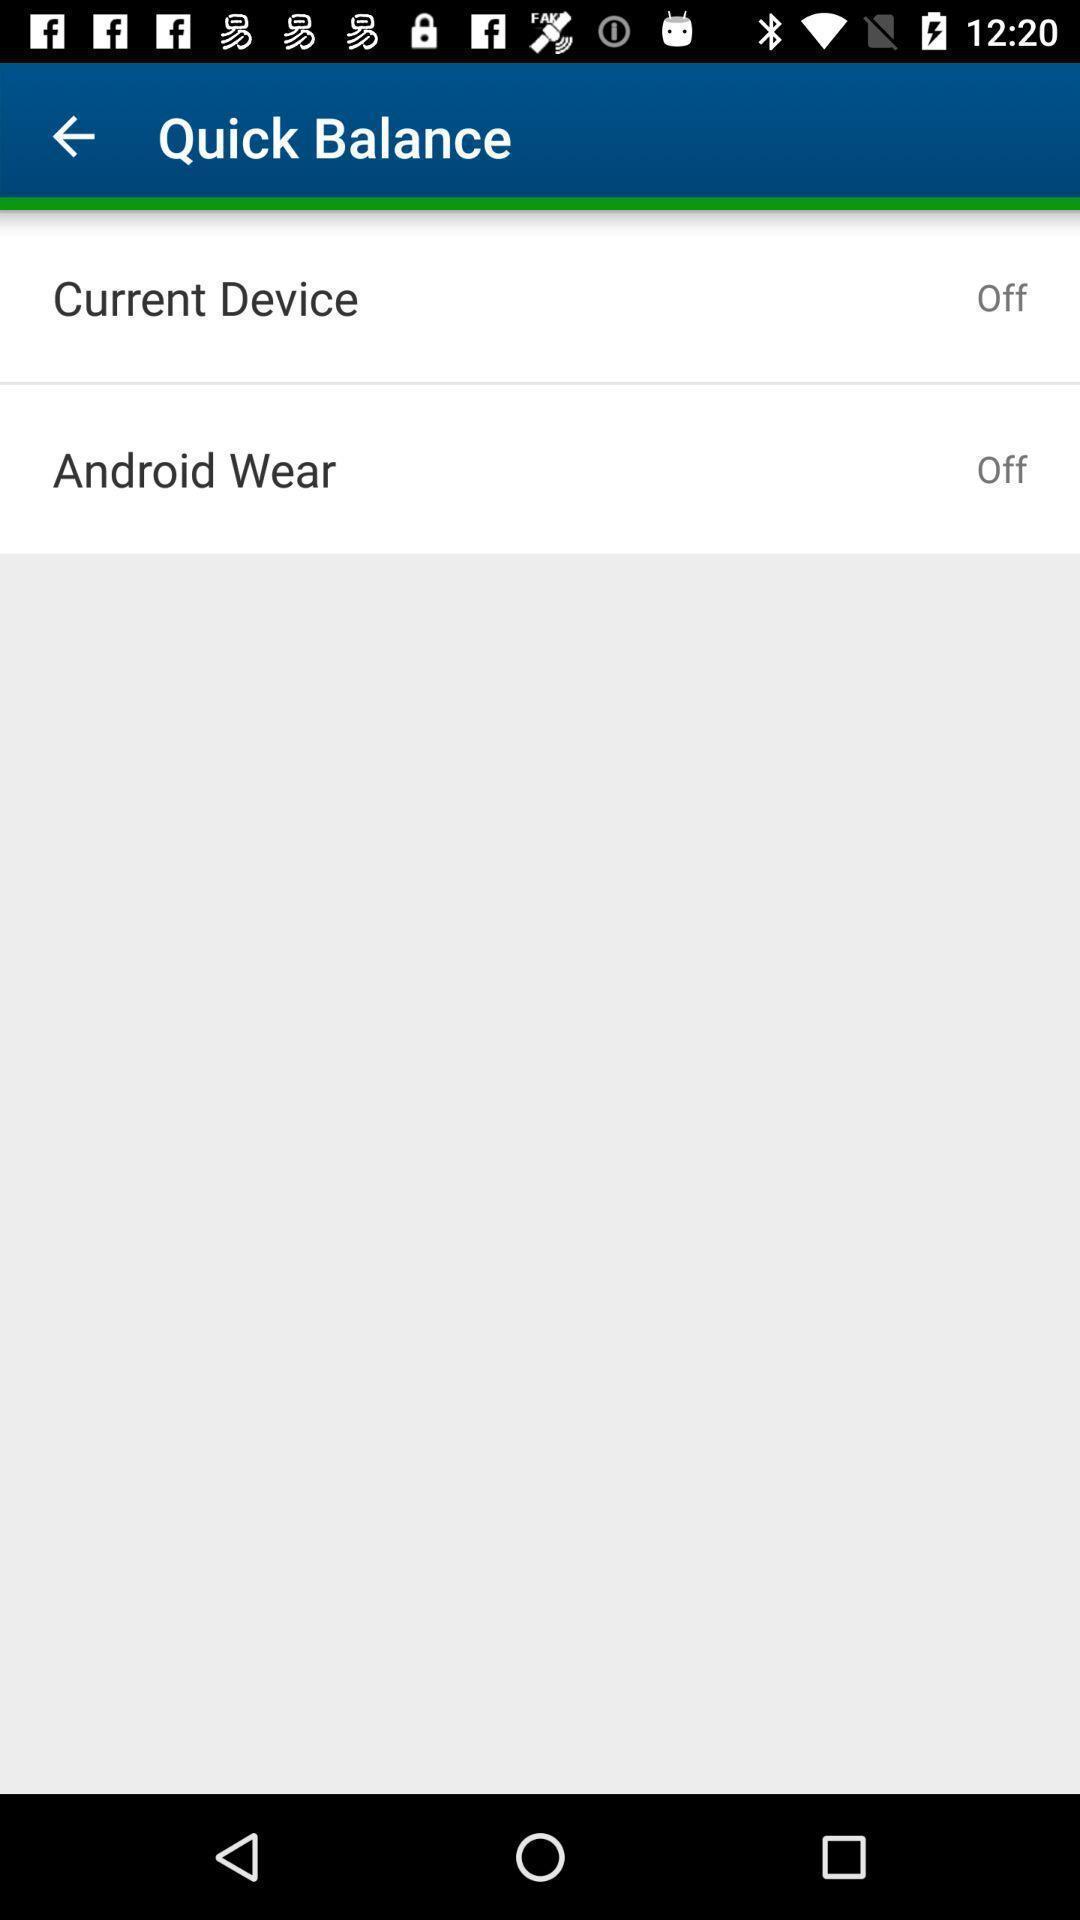Summarize the information in this screenshot. Page showing multiple options of app. 